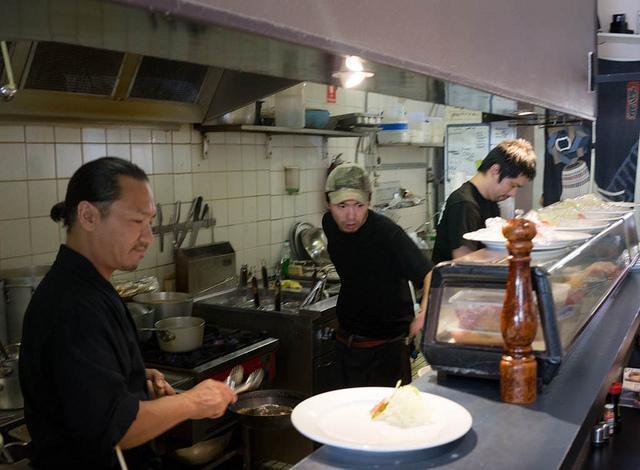How many people are in the kitchen?
Give a very brief answer. 3. How many people are there?
Give a very brief answer. 3. 